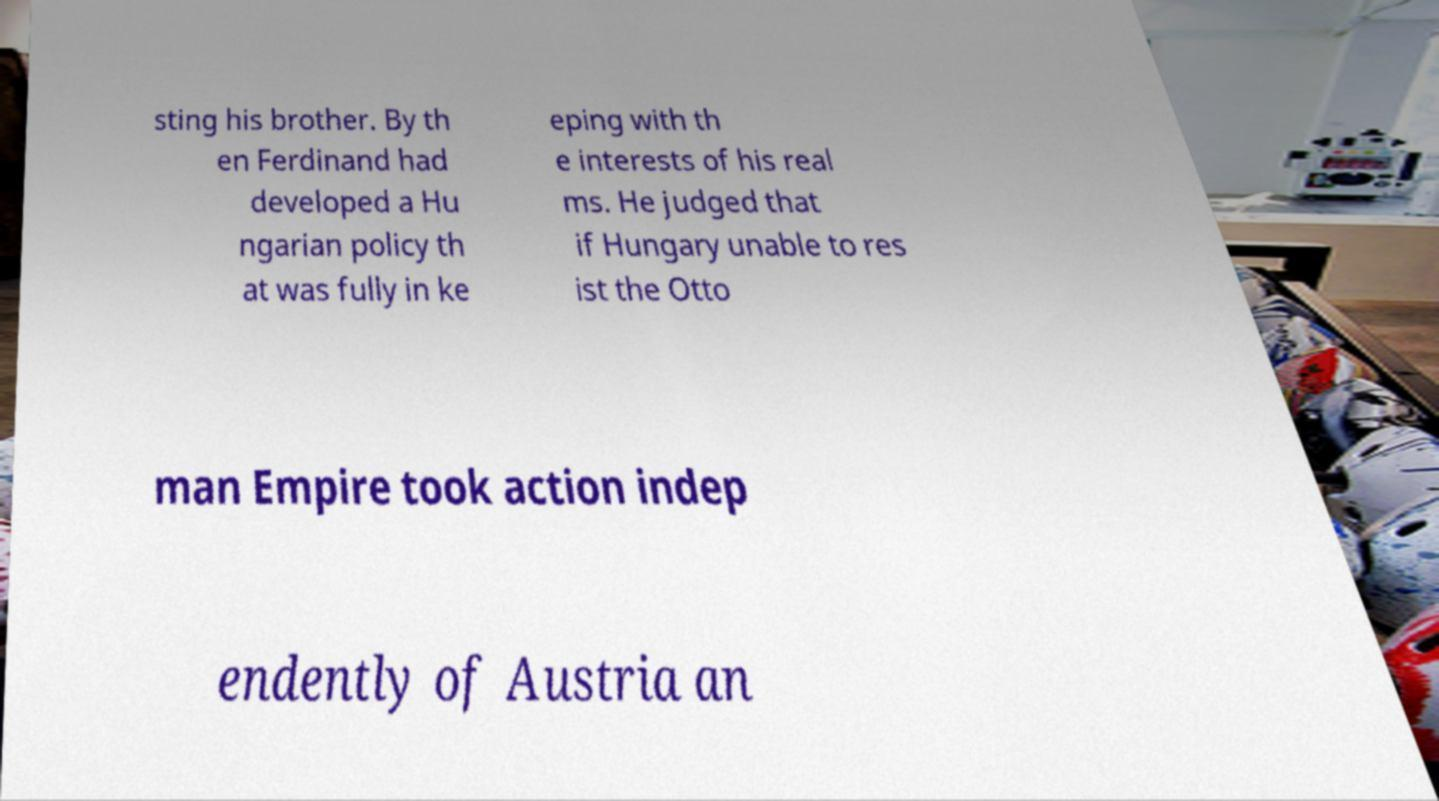Can you read and provide the text displayed in the image?This photo seems to have some interesting text. Can you extract and type it out for me? sting his brother. By th en Ferdinand had developed a Hu ngarian policy th at was fully in ke eping with th e interests of his real ms. He judged that if Hungary unable to res ist the Otto man Empire took action indep endently of Austria an 